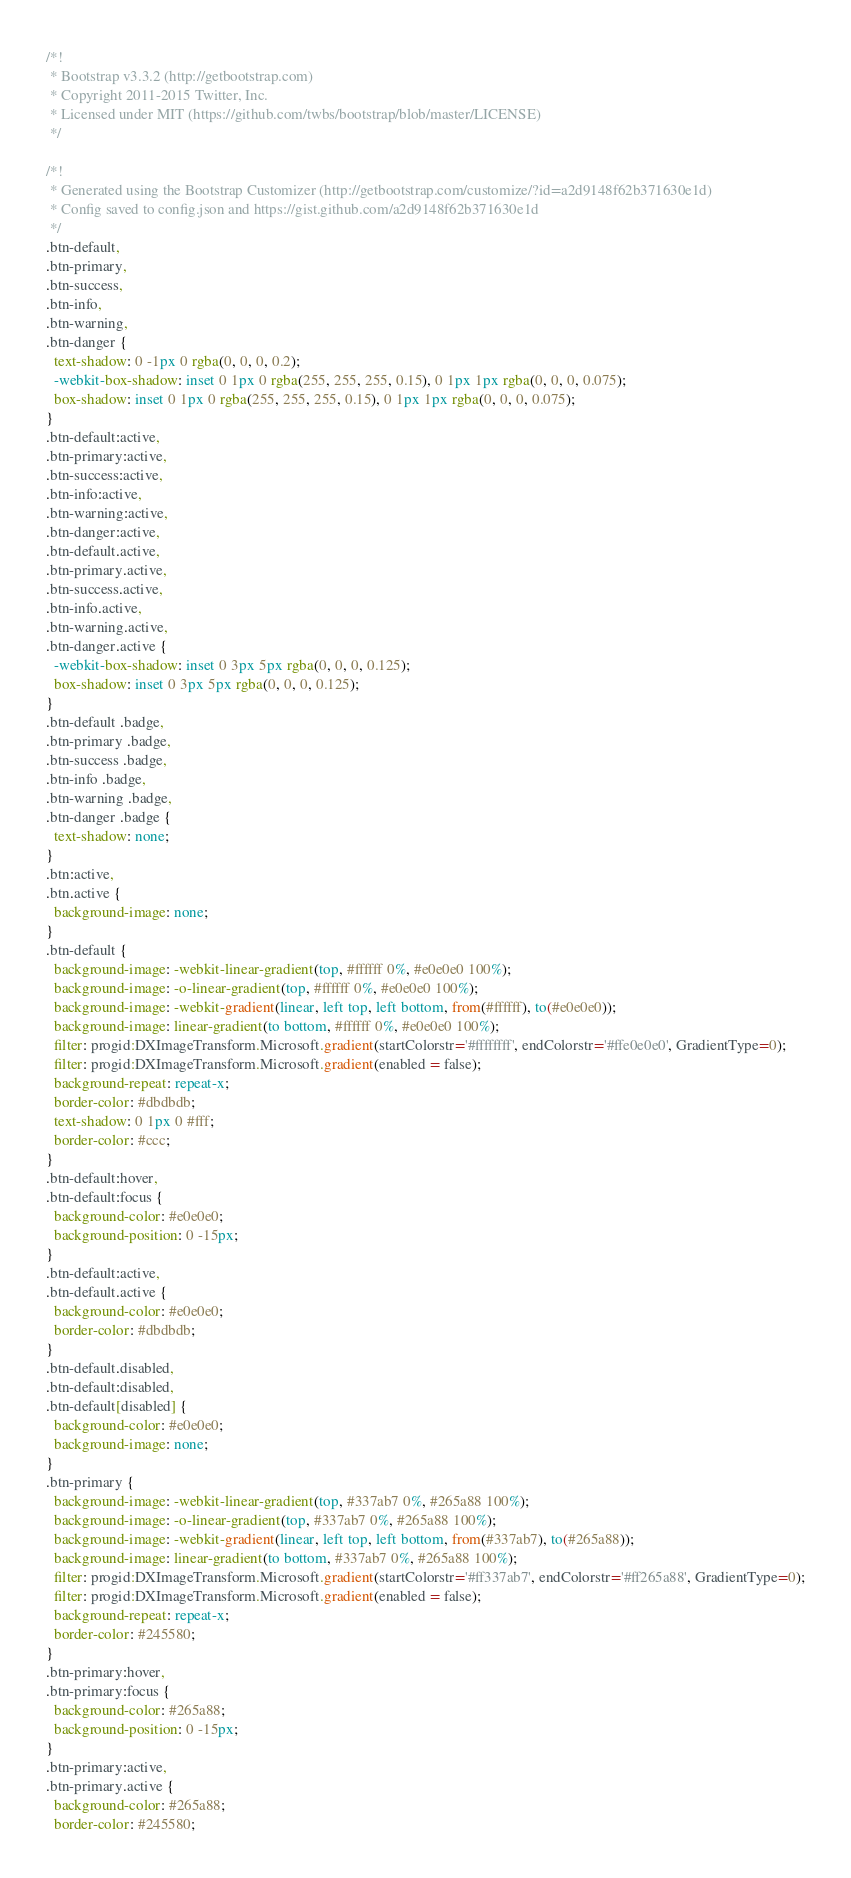<code> <loc_0><loc_0><loc_500><loc_500><_CSS_>/*!
 * Bootstrap v3.3.2 (http://getbootstrap.com)
 * Copyright 2011-2015 Twitter, Inc.
 * Licensed under MIT (https://github.com/twbs/bootstrap/blob/master/LICENSE)
 */

/*!
 * Generated using the Bootstrap Customizer (http://getbootstrap.com/customize/?id=a2d9148f62b371630e1d)
 * Config saved to config.json and https://gist.github.com/a2d9148f62b371630e1d
 */
.btn-default,
.btn-primary,
.btn-success,
.btn-info,
.btn-warning,
.btn-danger {
  text-shadow: 0 -1px 0 rgba(0, 0, 0, 0.2);
  -webkit-box-shadow: inset 0 1px 0 rgba(255, 255, 255, 0.15), 0 1px 1px rgba(0, 0, 0, 0.075);
  box-shadow: inset 0 1px 0 rgba(255, 255, 255, 0.15), 0 1px 1px rgba(0, 0, 0, 0.075);
}
.btn-default:active,
.btn-primary:active,
.btn-success:active,
.btn-info:active,
.btn-warning:active,
.btn-danger:active,
.btn-default.active,
.btn-primary.active,
.btn-success.active,
.btn-info.active,
.btn-warning.active,
.btn-danger.active {
  -webkit-box-shadow: inset 0 3px 5px rgba(0, 0, 0, 0.125);
  box-shadow: inset 0 3px 5px rgba(0, 0, 0, 0.125);
}
.btn-default .badge,
.btn-primary .badge,
.btn-success .badge,
.btn-info .badge,
.btn-warning .badge,
.btn-danger .badge {
  text-shadow: none;
}
.btn:active,
.btn.active {
  background-image: none;
}
.btn-default {
  background-image: -webkit-linear-gradient(top, #ffffff 0%, #e0e0e0 100%);
  background-image: -o-linear-gradient(top, #ffffff 0%, #e0e0e0 100%);
  background-image: -webkit-gradient(linear, left top, left bottom, from(#ffffff), to(#e0e0e0));
  background-image: linear-gradient(to bottom, #ffffff 0%, #e0e0e0 100%);
  filter: progid:DXImageTransform.Microsoft.gradient(startColorstr='#ffffffff', endColorstr='#ffe0e0e0', GradientType=0);
  filter: progid:DXImageTransform.Microsoft.gradient(enabled = false);
  background-repeat: repeat-x;
  border-color: #dbdbdb;
  text-shadow: 0 1px 0 #fff;
  border-color: #ccc;
}
.btn-default:hover,
.btn-default:focus {
  background-color: #e0e0e0;
  background-position: 0 -15px;
}
.btn-default:active,
.btn-default.active {
  background-color: #e0e0e0;
  border-color: #dbdbdb;
}
.btn-default.disabled,
.btn-default:disabled,
.btn-default[disabled] {
  background-color: #e0e0e0;
  background-image: none;
}
.btn-primary {
  background-image: -webkit-linear-gradient(top, #337ab7 0%, #265a88 100%);
  background-image: -o-linear-gradient(top, #337ab7 0%, #265a88 100%);
  background-image: -webkit-gradient(linear, left top, left bottom, from(#337ab7), to(#265a88));
  background-image: linear-gradient(to bottom, #337ab7 0%, #265a88 100%);
  filter: progid:DXImageTransform.Microsoft.gradient(startColorstr='#ff337ab7', endColorstr='#ff265a88', GradientType=0);
  filter: progid:DXImageTransform.Microsoft.gradient(enabled = false);
  background-repeat: repeat-x;
  border-color: #245580;
}
.btn-primary:hover,
.btn-primary:focus {
  background-color: #265a88;
  background-position: 0 -15px;
}
.btn-primary:active,
.btn-primary.active {
  background-color: #265a88;
  border-color: #245580;</code> 